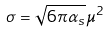Convert formula to latex. <formula><loc_0><loc_0><loc_500><loc_500>\sigma = \sqrt { 6 \pi \alpha _ { s } } \mu ^ { 2 }</formula> 